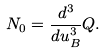Convert formula to latex. <formula><loc_0><loc_0><loc_500><loc_500>N _ { 0 } = \frac { d ^ { 3 } } { d u _ { B } ^ { 3 } } Q .</formula> 